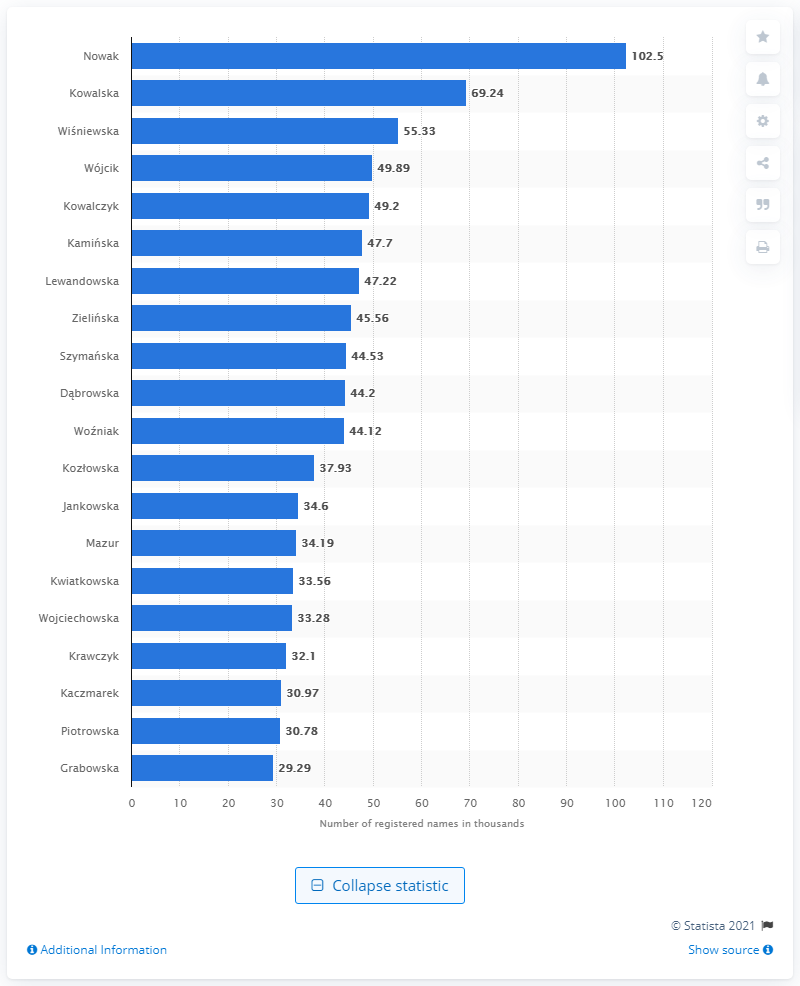Point out several critical features in this image. According to the most recent data from February 2021, Nowak was the most popular female last name in Poland. 